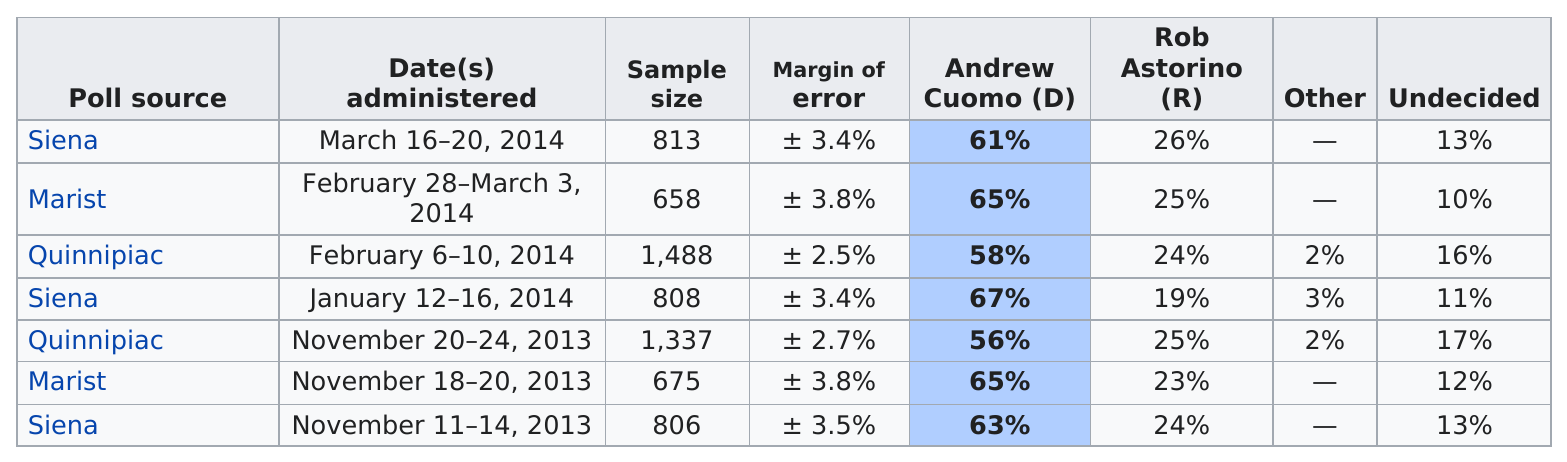Outline some significant characteristics in this image. In four out of the poll sources reviewed, Rob Astorino did not receive support from more than 25% of the voters. The sample size of Siena is smaller than the sample size of Quinnipiac. The Democrats possess the lead in this election. The difference in percentage between Governor Cuomo and his opponent, Rob Astorino, from February 28-March 3, 2014, was approximately 40%. There were four polls out of a total of seven in which more than 12% of those polled were undecided. 